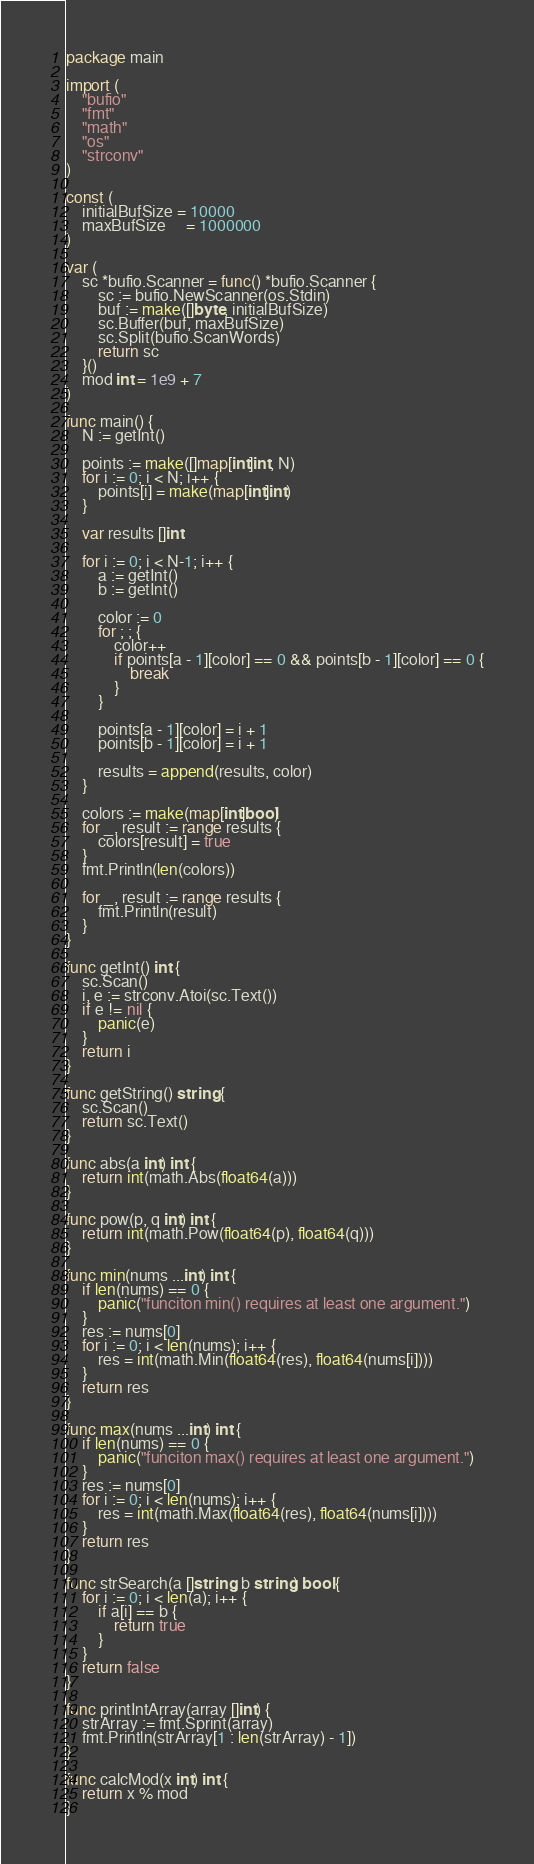<code> <loc_0><loc_0><loc_500><loc_500><_Go_>package main

import (
	"bufio"
	"fmt"
	"math"
	"os"
	"strconv"
)

const (
	initialBufSize = 10000
	maxBufSize     = 1000000
)

var (
	sc *bufio.Scanner = func() *bufio.Scanner {
		sc := bufio.NewScanner(os.Stdin)
		buf := make([]byte, initialBufSize)
		sc.Buffer(buf, maxBufSize)
		sc.Split(bufio.ScanWords)
		return sc
	}()
	mod int = 1e9 + 7
)

func main() {
	N := getInt()

	points := make([]map[int]int, N)
	for i := 0; i < N; i++ {
		points[i] = make(map[int]int)
	}

	var results []int

	for i := 0; i < N-1; i++ {
		a := getInt()
		b := getInt()

		color := 0
		for ; ; {
			color++
			if points[a - 1][color] == 0 && points[b - 1][color] == 0 {
				break
			}
		}

		points[a - 1][color] = i + 1
		points[b - 1][color] = i + 1

		results = append(results, color)
	}

	colors := make(map[int]bool)
	for _, result := range results {
		colors[result] = true
	}
	fmt.Println(len(colors))

	for _, result := range results {
		fmt.Println(result)
	}
}

func getInt() int {
	sc.Scan()
	i, e := strconv.Atoi(sc.Text())
	if e != nil {
		panic(e)
	}
	return i
}

func getString() string {
	sc.Scan()
	return sc.Text()
}

func abs(a int) int {
	return int(math.Abs(float64(a)))
}

func pow(p, q int) int {
	return int(math.Pow(float64(p), float64(q)))
}

func min(nums ...int) int {
	if len(nums) == 0 {
		panic("funciton min() requires at least one argument.")
	}
	res := nums[0]
	for i := 0; i < len(nums); i++ {
		res = int(math.Min(float64(res), float64(nums[i])))
	}
	return res
}

func max(nums ...int) int {
	if len(nums) == 0 {
		panic("funciton max() requires at least one argument.")
	}
	res := nums[0]
	for i := 0; i < len(nums); i++ {
		res = int(math.Max(float64(res), float64(nums[i])))
	}
	return res
}

func strSearch(a []string, b string) bool {
	for i := 0; i < len(a); i++ {
		if a[i] == b {
			return true
		}
	}
	return false
}

func printIntArray(array []int) {
	strArray := fmt.Sprint(array)
	fmt.Println(strArray[1 : len(strArray) - 1])
}

func calcMod(x int) int {
	return x % mod
}
</code> 